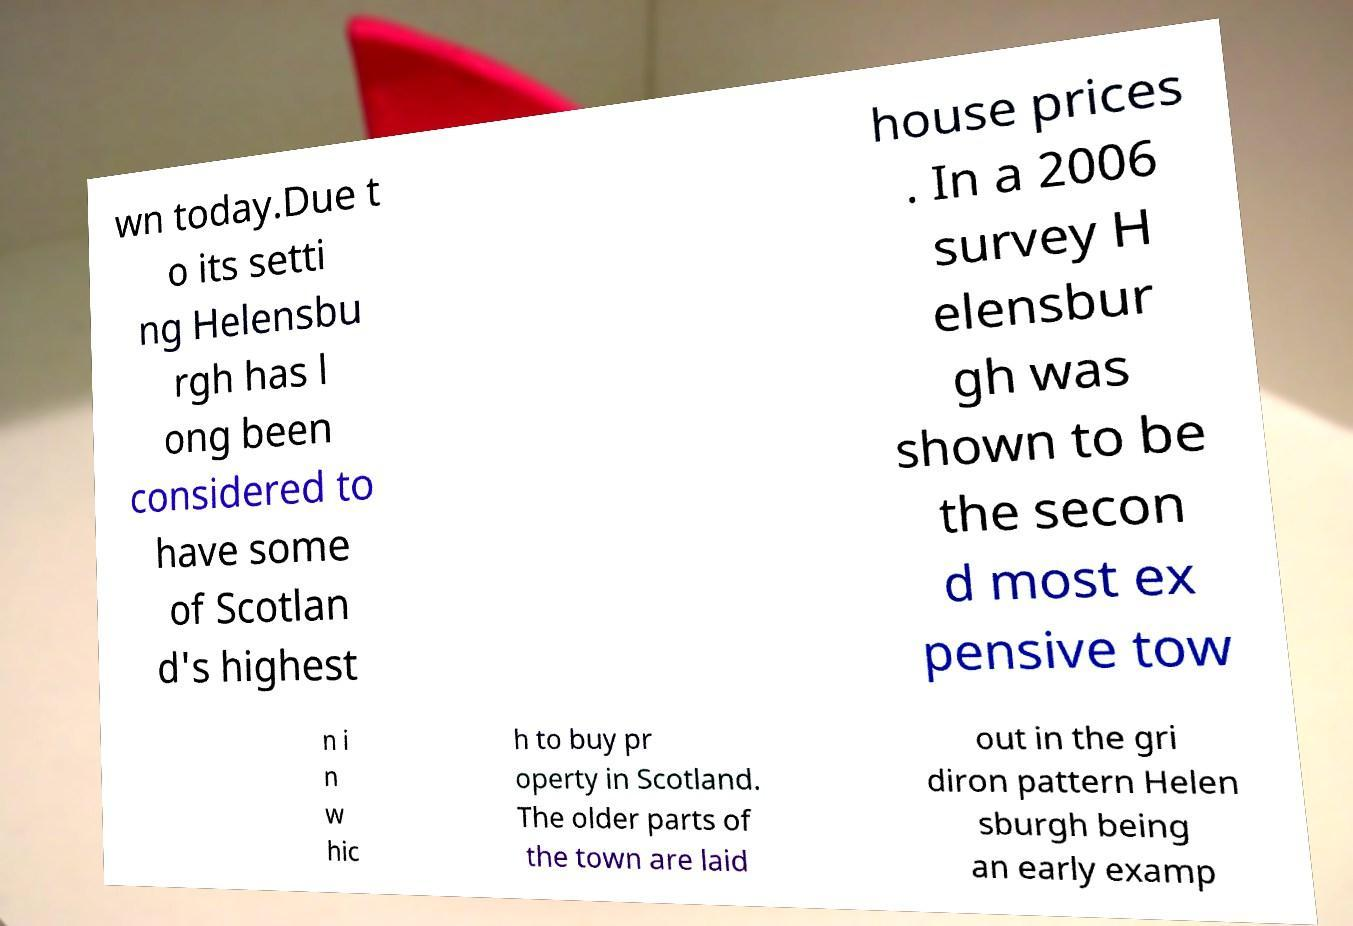Could you extract and type out the text from this image? wn today.Due t o its setti ng Helensbu rgh has l ong been considered to have some of Scotlan d's highest house prices . In a 2006 survey H elensbur gh was shown to be the secon d most ex pensive tow n i n w hic h to buy pr operty in Scotland. The older parts of the town are laid out in the gri diron pattern Helen sburgh being an early examp 